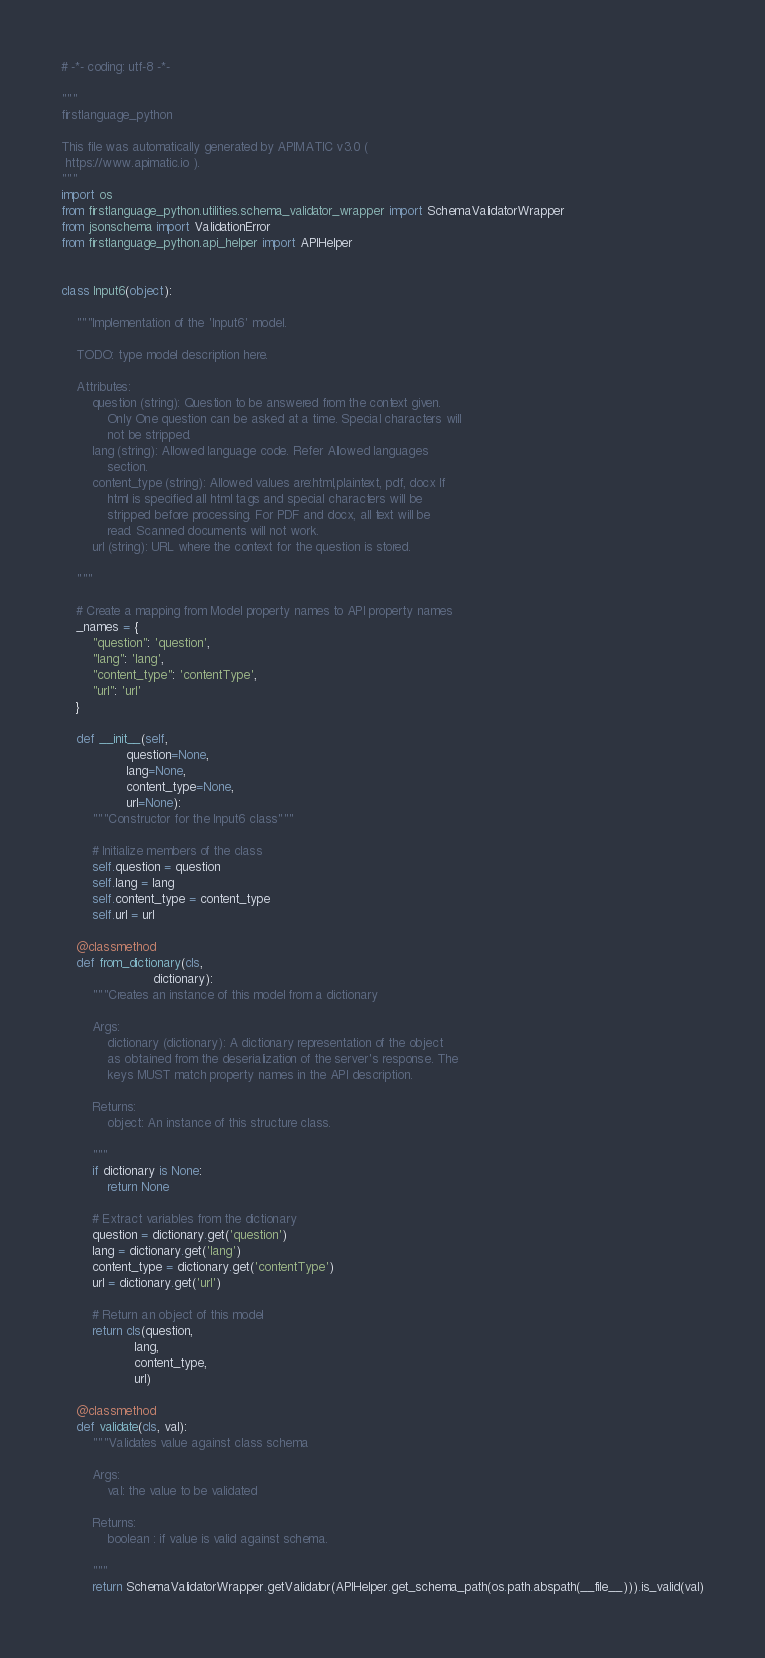Convert code to text. <code><loc_0><loc_0><loc_500><loc_500><_Python_># -*- coding: utf-8 -*-

"""
firstlanguage_python

This file was automatically generated by APIMATIC v3.0 (
 https://www.apimatic.io ).
"""
import os
from firstlanguage_python.utilities.schema_validator_wrapper import SchemaValidatorWrapper
from jsonschema import ValidationError
from firstlanguage_python.api_helper import APIHelper


class Input6(object):

    """Implementation of the 'Input6' model.

    TODO: type model description here.

    Attributes:
        question (string): Question to be answered from the context given.
            Only One question can be asked at a time. Special characters will
            not be stripped.
        lang (string): Allowed language code. Refer Allowed languages
            section.
        content_type (string): Allowed values are:html,plaintext, pdf, docx If
            html is specified all html tags and special characters will be
            stripped before processing. For PDF and docx, all text will be
            read. Scanned documents will not work.
        url (string): URL where the context for the question is stored.

    """

    # Create a mapping from Model property names to API property names
    _names = {
        "question": 'question',
        "lang": 'lang',
        "content_type": 'contentType',
        "url": 'url'
    }

    def __init__(self,
                 question=None,
                 lang=None,
                 content_type=None,
                 url=None):
        """Constructor for the Input6 class"""

        # Initialize members of the class
        self.question = question
        self.lang = lang
        self.content_type = content_type
        self.url = url

    @classmethod
    def from_dictionary(cls,
                        dictionary):
        """Creates an instance of this model from a dictionary

        Args:
            dictionary (dictionary): A dictionary representation of the object
            as obtained from the deserialization of the server's response. The
            keys MUST match property names in the API description.

        Returns:
            object: An instance of this structure class.

        """
        if dictionary is None:
            return None

        # Extract variables from the dictionary
        question = dictionary.get('question')
        lang = dictionary.get('lang')
        content_type = dictionary.get('contentType')
        url = dictionary.get('url')

        # Return an object of this model
        return cls(question,
                   lang,
                   content_type,
                   url)

    @classmethod
    def validate(cls, val):
        """Validates value against class schema

        Args:
            val: the value to be validated

        Returns:
            boolean : if value is valid against schema.

        """
        return SchemaValidatorWrapper.getValidator(APIHelper.get_schema_path(os.path.abspath(__file__))).is_valid(val)
</code> 